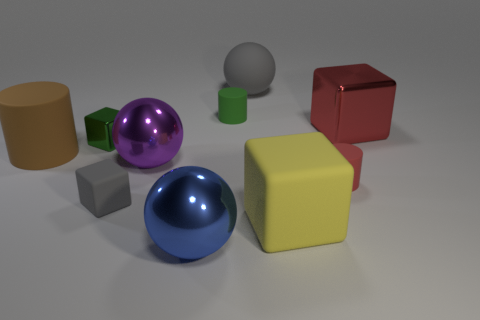Subtract all red rubber cylinders. How many cylinders are left? 2 Subtract 2 cylinders. How many cylinders are left? 1 Subtract all yellow cubes. How many cubes are left? 3 Subtract all spheres. How many objects are left? 7 Add 3 large green shiny blocks. How many large green shiny blocks exist? 3 Subtract 0 yellow balls. How many objects are left? 10 Subtract all purple blocks. Subtract all cyan cylinders. How many blocks are left? 4 Subtract all red spheres. How many green cylinders are left? 1 Subtract all large red shiny blocks. Subtract all large spheres. How many objects are left? 6 Add 8 gray spheres. How many gray spheres are left? 9 